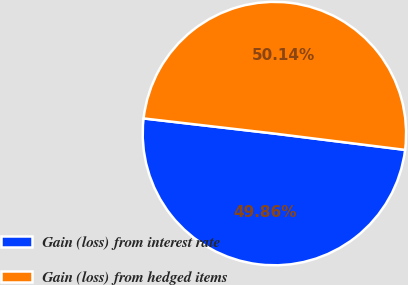Convert chart. <chart><loc_0><loc_0><loc_500><loc_500><pie_chart><fcel>Gain (loss) from interest rate<fcel>Gain (loss) from hedged items<nl><fcel>49.86%<fcel>50.14%<nl></chart> 